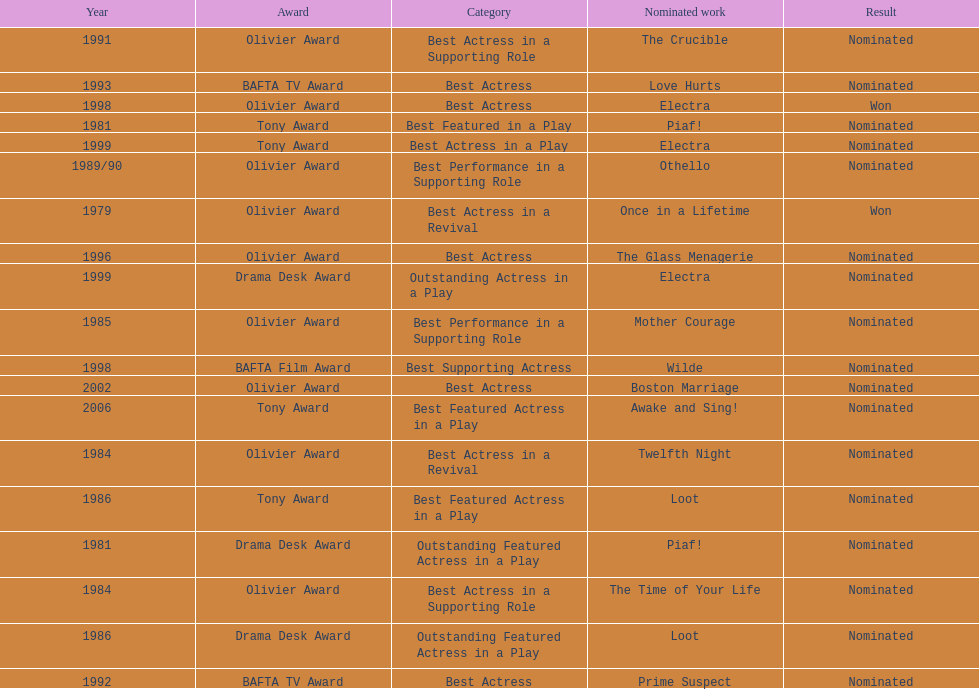What play was wanamaker nominated for best featured in a play in 1981? Piaf!. 